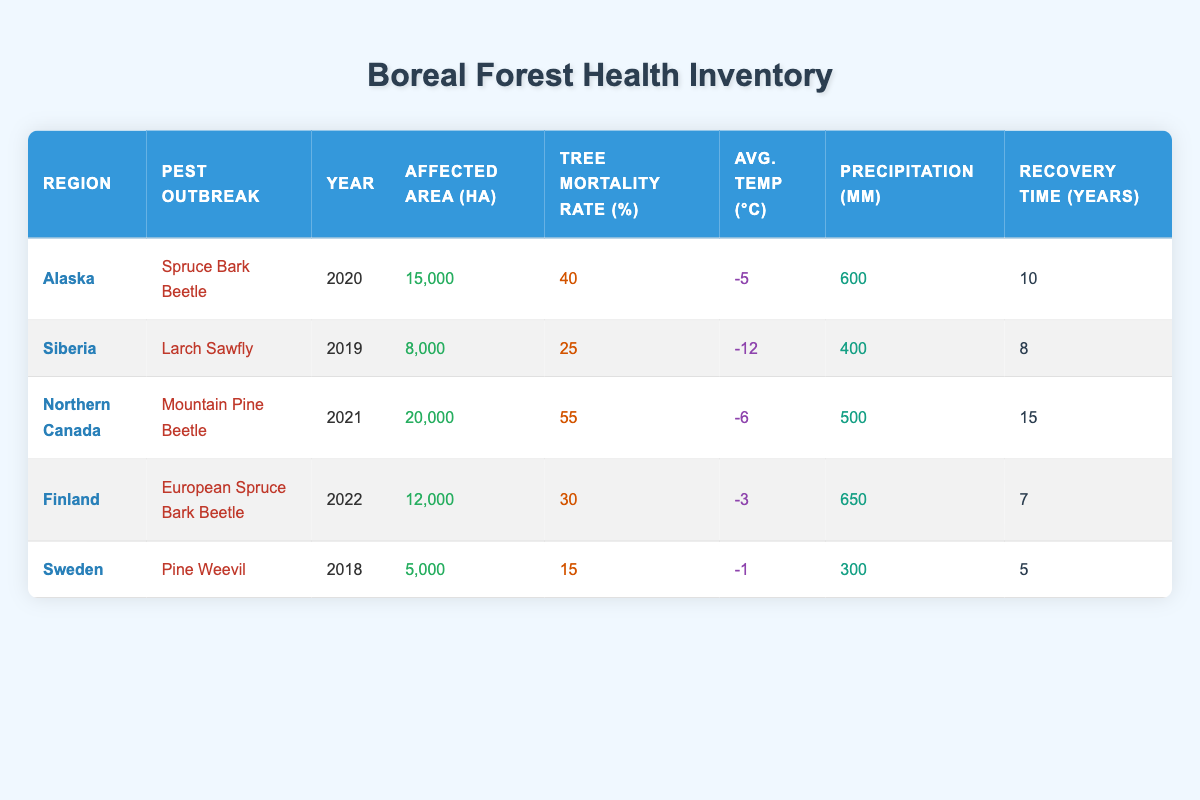What year did the Mountain Pine Beetle outbreak occur in Northern Canada? The table lists the year of pest outbreaks for specific regions. Looking at the row for Northern Canada, the pest outbreak is recorded as occurring in 2021.
Answer: 2021 Which region experienced the highest tree mortality rate from pest outbreaks? By examining the tree mortality rates in the table, the rates are 40% for Alaska, 25% for Siberia, 55% for Northern Canada, 30% for Finland, and 15% for Sweden. The highest rate is 55% in Northern Canada.
Answer: Northern Canada What is the total affected area (in hectares) from the pest outbreaks listed in the table? To find the total affected area, we sum the affected areas: 15,000 + 8,000 + 20,000 + 12,000 + 5,000 = 60,000 hectares.
Answer: 60000 Did Finland have a higher average temperature than Sweden during the pest outbreaks? Checking the average temperatures, Finland's average temperature is -3°C, while Sweden's is -1°C. Since -3°C is lower than -1°C, Finland did not have a higher temperature.
Answer: No What is the average recovery time for forest health across all regions affected by pest outbreaks? The recovery times listed are 10, 8, 15, 7, and 5 years. To find the average, we sum these values (10 + 8 + 15 + 7 + 5 = 45) and divide by the number of regions (45 / 5 = 9). The average recovery time is 9 years.
Answer: 9 years Which pest outbreak had the lowest affected area? By reviewing the affected areas listed in the table, we find that Sweden's Pine Weevil outbreak affected 5,000 hectares, which is the lowest when compared to other regions.
Answer: Pine Weevil Is the precipitation level in Alaska higher than in Sweden? According to the table, Alaska received 600 mm of precipitation, while Sweden received 300 mm. Since 600 mm is greater than 300 mm, it confirms that Alaska had higher precipitation.
Answer: Yes What is the difference in affected area between the outbreak in Northern Canada and the one in Finland? The affected area in Northern Canada is 20,000 hectares, and in Finland, it is 12,000 hectares. The difference is calculated as 20,000 - 12,000 = 8,000 hectares.
Answer: 8000 